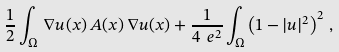Convert formula to latex. <formula><loc_0><loc_0><loc_500><loc_500>\frac { 1 } { 2 } \int _ { \Omega } \, \nabla u ( x ) \, A ( x ) \, \nabla u ( x ) + \frac { 1 } { 4 \ e ^ { 2 } } \int _ { \Omega } \left ( 1 - | u | ^ { 2 } \right ) ^ { 2 } \, ,</formula> 